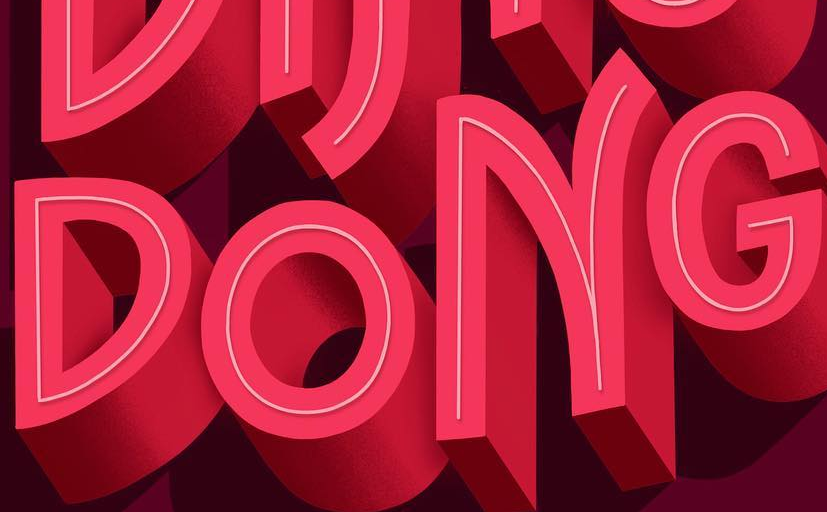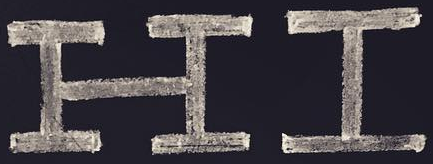Identify the words shown in these images in order, separated by a semicolon. DONG; HI 